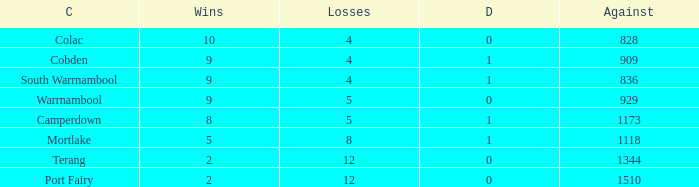What is the sum of wins for Port Fairy with under 1510 against? None. Would you be able to parse every entry in this table? {'header': ['C', 'Wins', 'Losses', 'D', 'Against'], 'rows': [['Colac', '10', '4', '0', '828'], ['Cobden', '9', '4', '1', '909'], ['South Warrnambool', '9', '4', '1', '836'], ['Warrnambool', '9', '5', '0', '929'], ['Camperdown', '8', '5', '1', '1173'], ['Mortlake', '5', '8', '1', '1118'], ['Terang', '2', '12', '0', '1344'], ['Port Fairy', '2', '12', '0', '1510']]} 